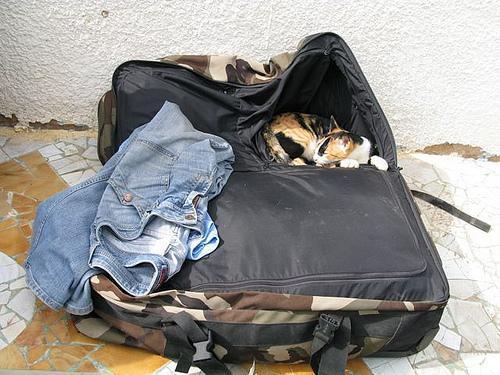How many suitcases are in the photo?
Give a very brief answer. 1. How many cats are in the photo?
Give a very brief answer. 1. 